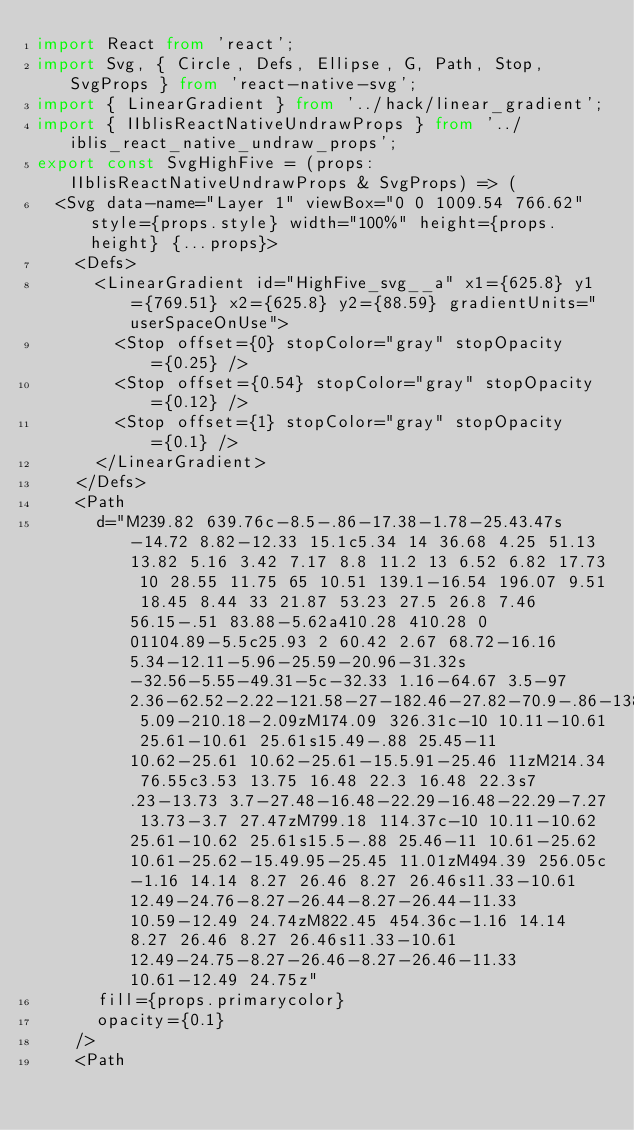Convert code to text. <code><loc_0><loc_0><loc_500><loc_500><_TypeScript_>import React from 'react';
import Svg, { Circle, Defs, Ellipse, G, Path, Stop, SvgProps } from 'react-native-svg';
import { LinearGradient } from '../hack/linear_gradient';
import { IIblisReactNativeUndrawProps } from '../iblis_react_native_undraw_props';
export const SvgHighFive = (props: IIblisReactNativeUndrawProps & SvgProps) => (
  <Svg data-name="Layer 1" viewBox="0 0 1009.54 766.62" style={props.style} width="100%" height={props.height} {...props}>
    <Defs>
      <LinearGradient id="HighFive_svg__a" x1={625.8} y1={769.51} x2={625.8} y2={88.59} gradientUnits="userSpaceOnUse">
        <Stop offset={0} stopColor="gray" stopOpacity={0.25} />
        <Stop offset={0.54} stopColor="gray" stopOpacity={0.12} />
        <Stop offset={1} stopColor="gray" stopOpacity={0.1} />
      </LinearGradient>
    </Defs>
    <Path
      d="M239.82 639.76c-8.5-.86-17.38-1.78-25.43.47s-14.72 8.82-12.33 15.1c5.34 14 36.68 4.25 51.13 13.82 5.16 3.42 7.17 8.8 11.2 13 6.52 6.82 17.73 10 28.55 11.75 65 10.51 139.1-16.54 196.07 9.51 18.45 8.44 33 21.87 53.23 27.5 26.8 7.46 56.15-.51 83.88-5.62a410.28 410.28 0 01104.89-5.5c25.93 2 60.42 2.67 68.72-16.16 5.34-12.11-5.96-25.59-20.96-31.32s-32.56-5.55-49.31-5c-32.33 1.16-64.67 3.5-97 2.36-62.52-2.22-121.58-27-182.46-27.82-70.9-.86-138.95 5.09-210.18-2.09zM174.09 326.31c-10 10.11-10.61 25.61-10.61 25.61s15.49-.88 25.45-11 10.62-25.61 10.62-25.61-15.5.91-25.46 11zM214.34 76.55c3.53 13.75 16.48 22.3 16.48 22.3s7.23-13.73 3.7-27.48-16.48-22.29-16.48-22.29-7.27 13.73-3.7 27.47zM799.18 114.37c-10 10.11-10.62 25.61-10.62 25.61s15.5-.88 25.46-11 10.61-25.62 10.61-25.62-15.49.95-25.45 11.01zM494.39 256.05c-1.16 14.14 8.27 26.46 8.27 26.46s11.33-10.61 12.49-24.76-8.27-26.44-8.27-26.44-11.33 10.59-12.49 24.74zM822.45 454.36c-1.16 14.14 8.27 26.46 8.27 26.46s11.33-10.61 12.49-24.75-8.27-26.46-8.27-26.46-11.33 10.61-12.49 24.75z"
      fill={props.primarycolor}
      opacity={0.1}
    />
    <Path</code> 